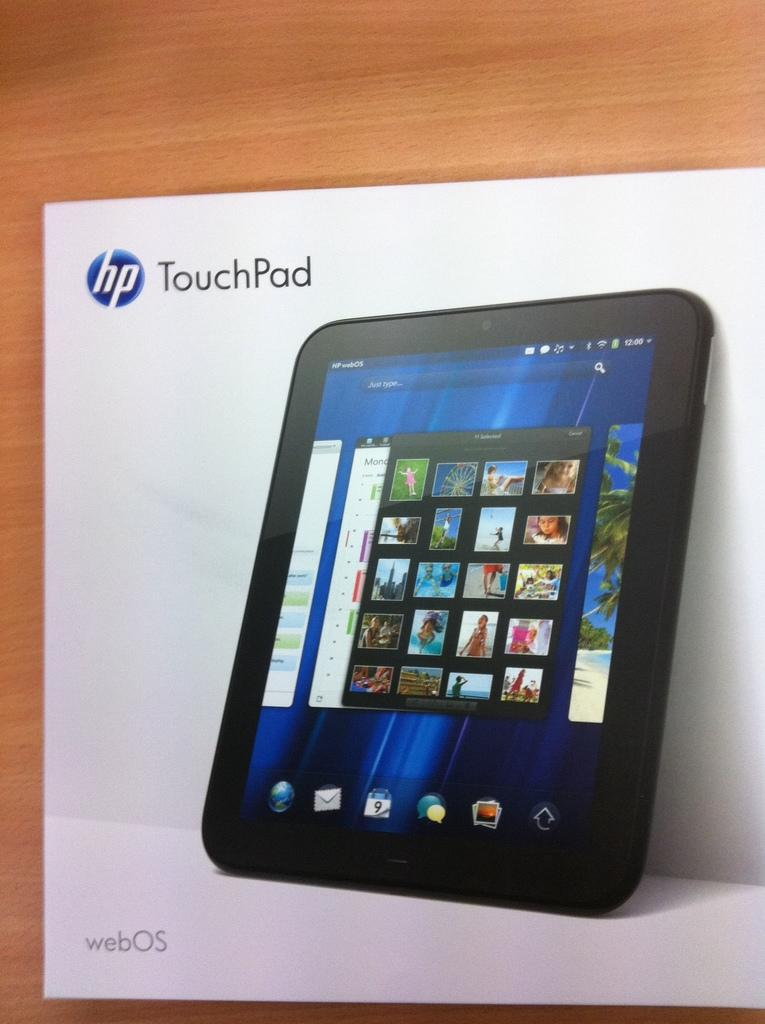What is placed on the table in the image? There is a paper on a table in the image. What type of love is expressed in the image? There is no indication of love or any emotional expression in the image; it only features a paper on a table. What degree of difficulty is depicted in the image? There is no indication of difficulty or any challenge in the image; it only features a paper on a table. 